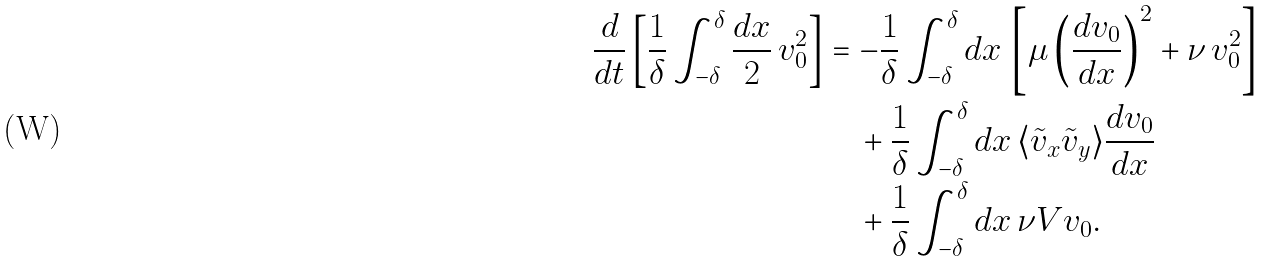<formula> <loc_0><loc_0><loc_500><loc_500>\frac { d } { d t } \left [ \frac { 1 } { \delta } \int _ { - \delta } ^ { \delta } \frac { d x } { 2 } \, v _ { 0 } ^ { 2 } \right ] & = - \frac { 1 } { \delta } \int _ { - \delta } ^ { \delta } d x \, \left [ \mu \left ( \frac { d v _ { 0 } } { d x } \right ) ^ { 2 } + \nu \, v _ { 0 } ^ { 2 } \right ] \\ & \quad + \frac { 1 } { \delta } \int _ { - \delta } ^ { \delta } d x \, \langle \tilde { v } _ { x } \tilde { v } _ { y } \rangle \frac { d v _ { 0 } } { d x } \\ & \quad + \frac { 1 } { \delta } \int _ { - \delta } ^ { \delta } d x \, \nu V v _ { 0 } .</formula> 